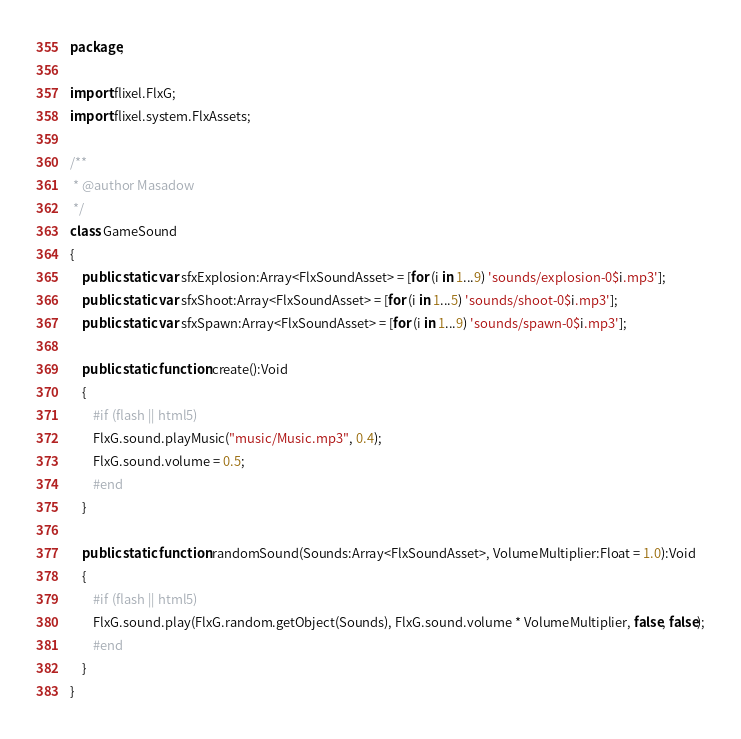<code> <loc_0><loc_0><loc_500><loc_500><_Haxe_>package;

import flixel.FlxG;
import flixel.system.FlxAssets;

/**
 * @author Masadow
 */
class GameSound
{
	public static var sfxExplosion:Array<FlxSoundAsset> = [for (i in 1...9) 'sounds/explosion-0$i.mp3'];
	public static var sfxShoot:Array<FlxSoundAsset> = [for (i in 1...5) 'sounds/shoot-0$i.mp3'];
	public static var sfxSpawn:Array<FlxSoundAsset> = [for (i in 1...9) 'sounds/spawn-0$i.mp3'];

	public static function create():Void
	{
		#if (flash || html5)
		FlxG.sound.playMusic("music/Music.mp3", 0.4);
		FlxG.sound.volume = 0.5;
		#end
	}
	
	public static function randomSound(Sounds:Array<FlxSoundAsset>, VolumeMultiplier:Float = 1.0):Void
	{
		#if (flash || html5)
		FlxG.sound.play(FlxG.random.getObject(Sounds), FlxG.sound.volume * VolumeMultiplier, false, false);
		#end
	}
}</code> 